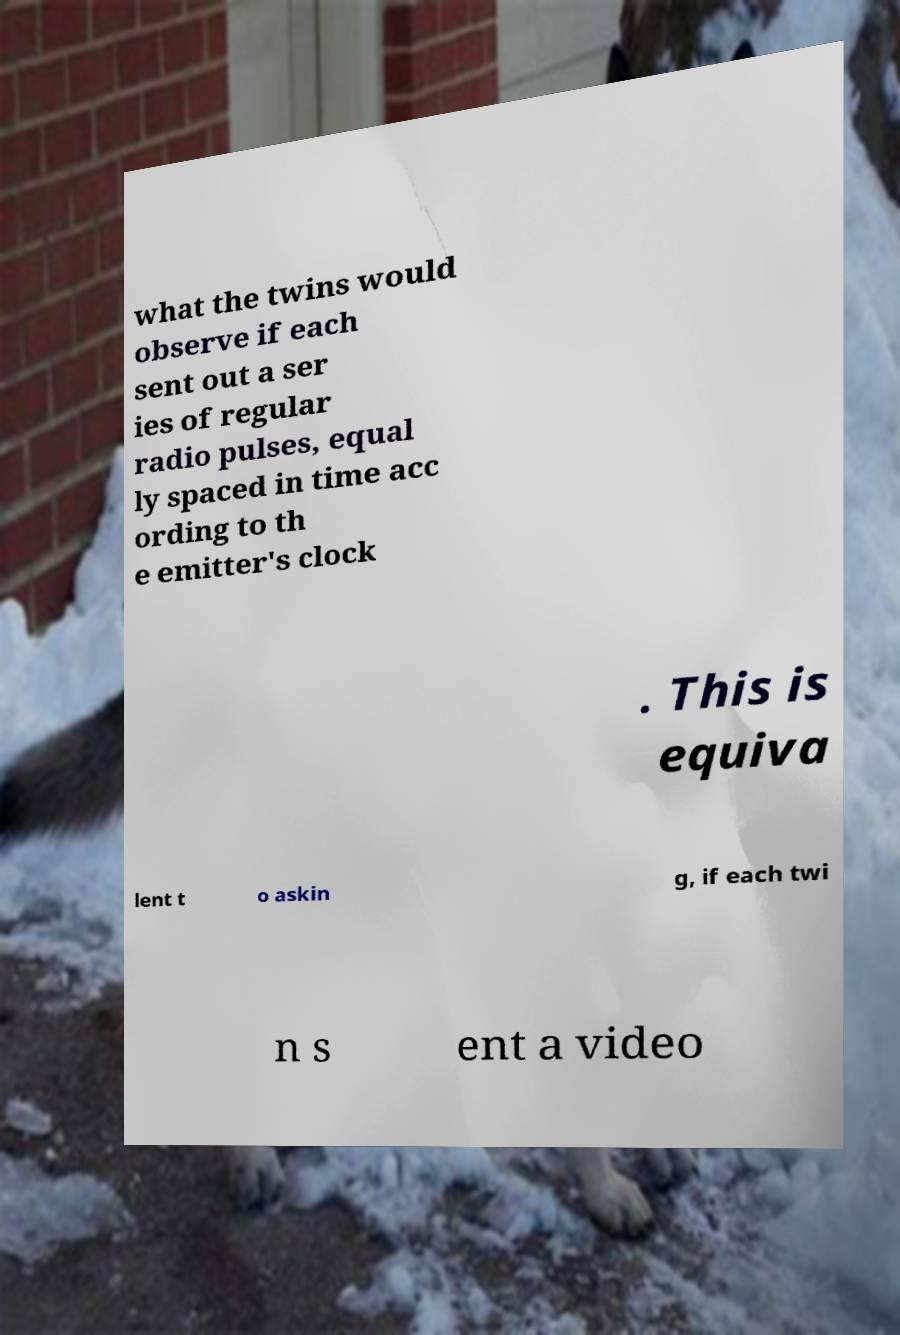Could you extract and type out the text from this image? what the twins would observe if each sent out a ser ies of regular radio pulses, equal ly spaced in time acc ording to th e emitter's clock . This is equiva lent t o askin g, if each twi n s ent a video 